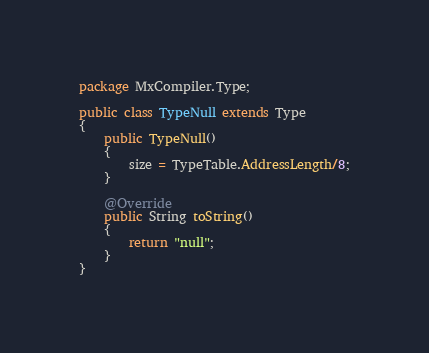Convert code to text. <code><loc_0><loc_0><loc_500><loc_500><_Java_>package MxCompiler.Type;

public class TypeNull extends Type
{
	public TypeNull()
	{
		size = TypeTable.AddressLength/8;
	}

	@Override
	public String toString()
	{
		return "null";
	}
}
</code> 